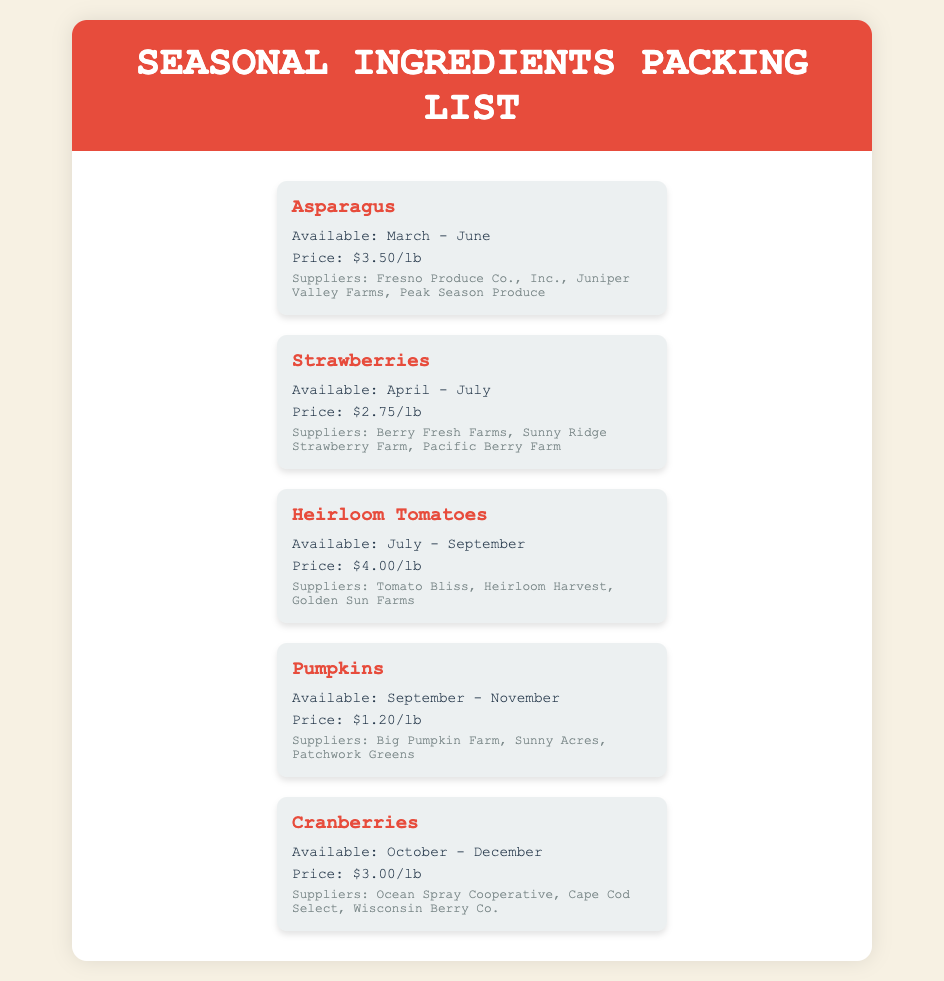What is the price of asparagus? Asparagus is listed in the document, and its price is specifically mentioned as $3.50/lb.
Answer: $3.50/lb When is the availability period for pumpkins? The document states that pumpkins are available from September to November.
Answer: September - November Which supplier provides strawberries? The document lists several suppliers for strawberries, one of which is Berry Fresh Farms.
Answer: Berry Fresh Farms What is the last ingredient listed in the document? By reviewing the ingredient cards, the last one is cranberries.
Answer: Cranberries How many suppliers are listed for heirloom tomatoes? The document specifies three suppliers for heirloom tomatoes: Tomato Bliss, Heirloom Harvest, and Golden Sun Farms.
Answer: 3 In which month do strawberries become available? The document states that strawberries are available starting in April.
Answer: April What is the availability period of cranberries? The document gives the availability of cranberries as October to December.
Answer: October - December What is the price of heirloom tomatoes? The price listed for heirloom tomatoes in the document is $4.00/lb.
Answer: $4.00/lb 